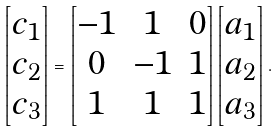<formula> <loc_0><loc_0><loc_500><loc_500>\begin{bmatrix} c _ { 1 } \\ c _ { 2 } \\ c _ { 3 } \end{bmatrix} = \begin{bmatrix} - 1 & 1 & 0 \\ 0 & - 1 & 1 \\ 1 & 1 & 1 \end{bmatrix} \begin{bmatrix} a _ { 1 } \\ a _ { 2 } \\ a _ { 3 } \end{bmatrix} .</formula> 